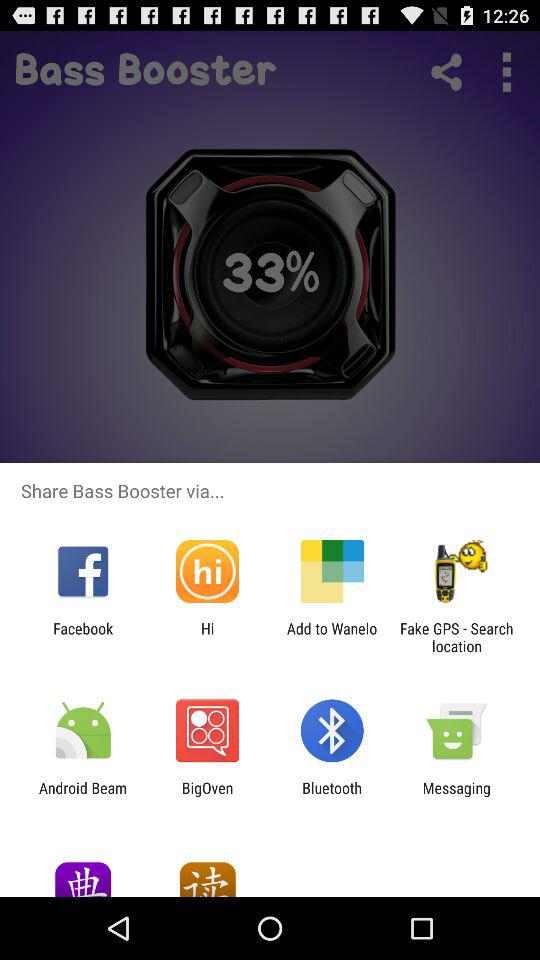What are the applications that can be used to share the "Bass Booster"? The applications that can be used to share the "Bass Booster" are "Facebook", "Hi", "Add to Wanelo", "Fake GPS - Search location", "Android Beam ", "BigOven", "Bluetooth" and "Messaging". 